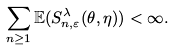Convert formula to latex. <formula><loc_0><loc_0><loc_500><loc_500>\sum _ { n \geq 1 } \mathbb { E } ( S _ { n , \varepsilon } ^ { \lambda } ( \theta , \eta ) ) < \infty .</formula> 